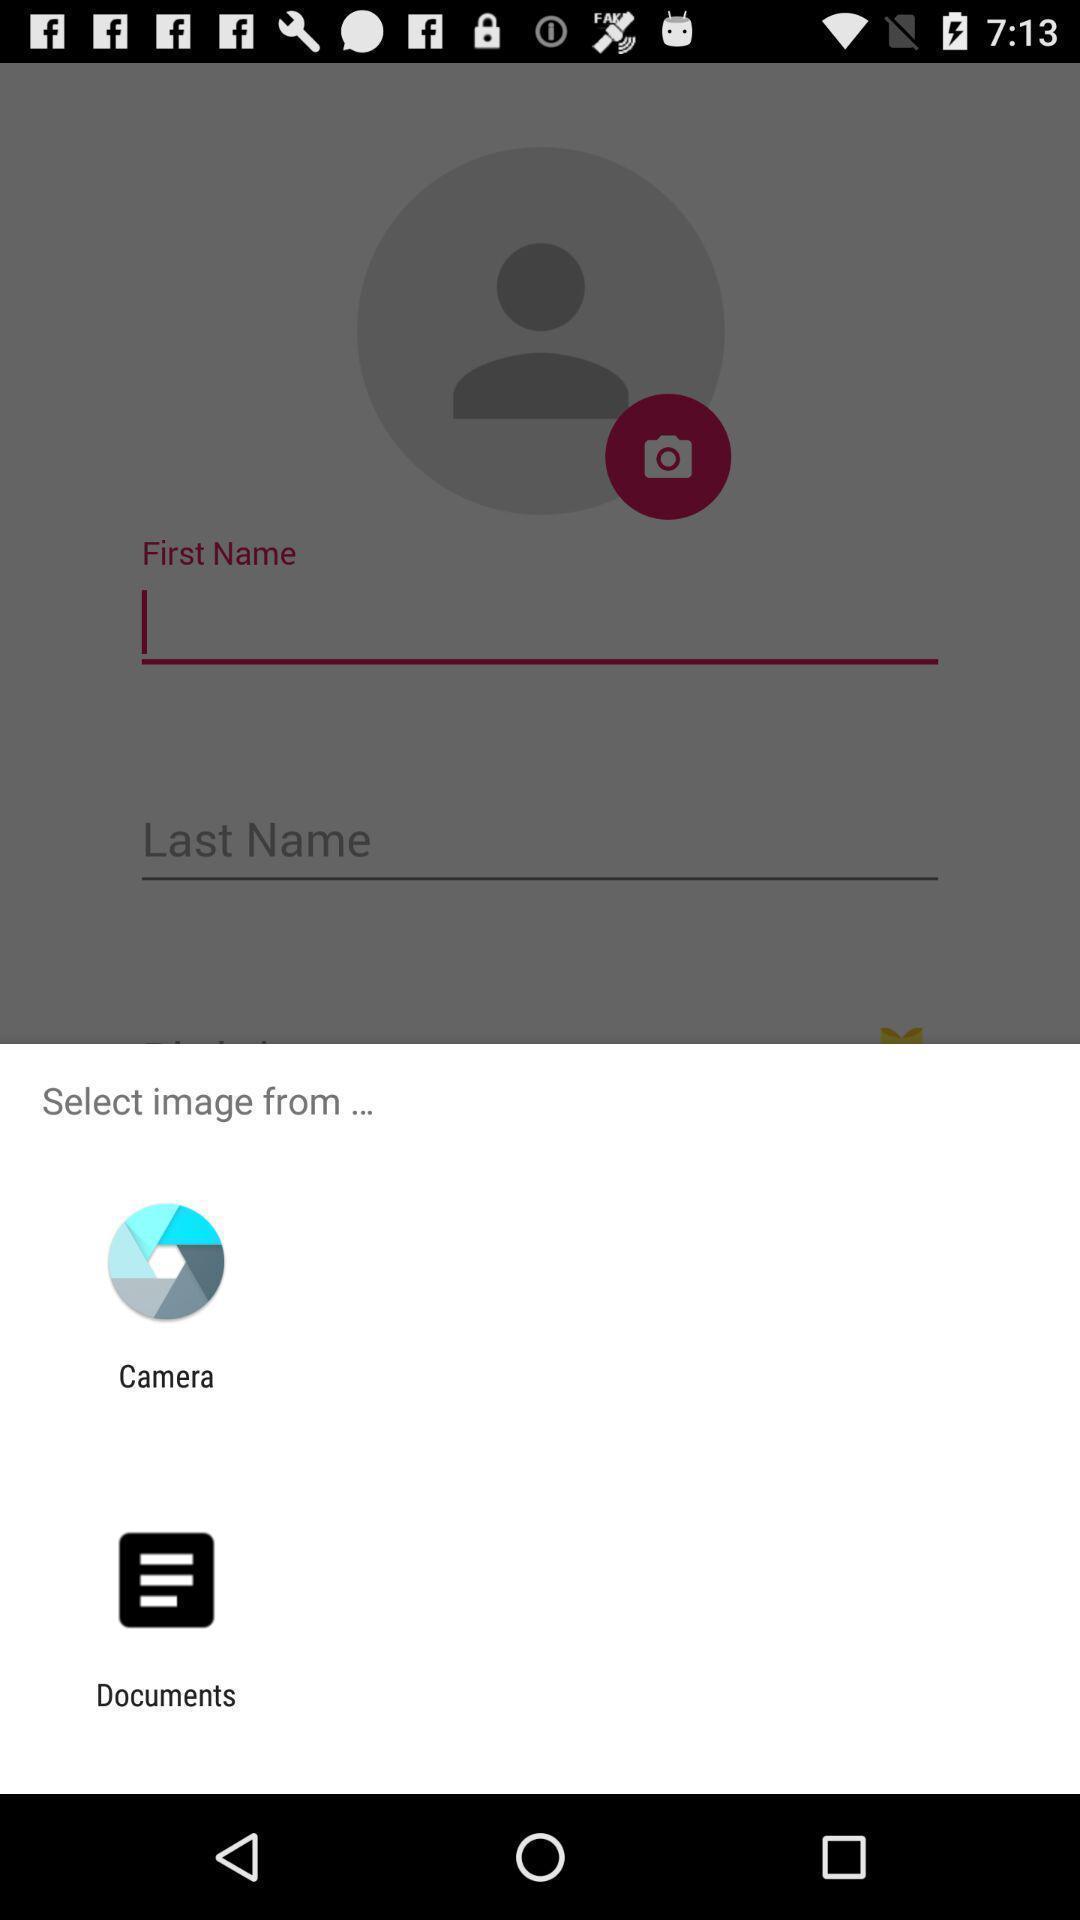What details can you identify in this image? Popup displaying applications to select image. 